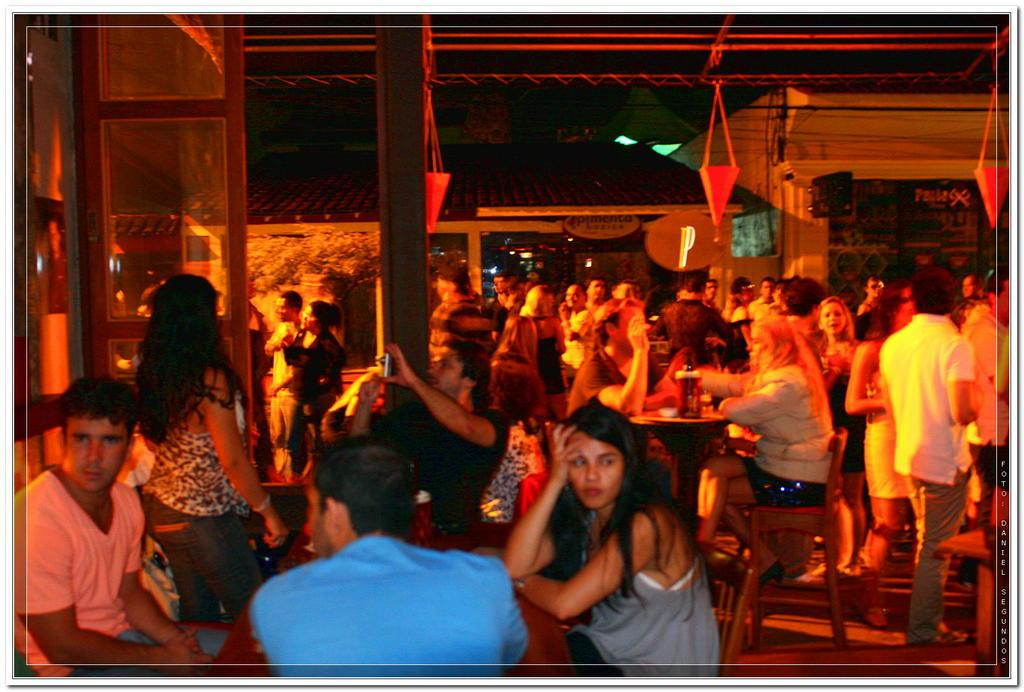How many people are present in the image? There are many people in the image. What are some people doing in the image? Some people are sitting on chairs. What can be seen in the image besides people? There are decorations, buildings in the background, and lights in the image. What type of beam is being used to heat the people in the image? There is no beam or heating element present in the image. What tool is being used to hammer the decorations in the image? There is no hammer or tool being used to install decorations in the image. 